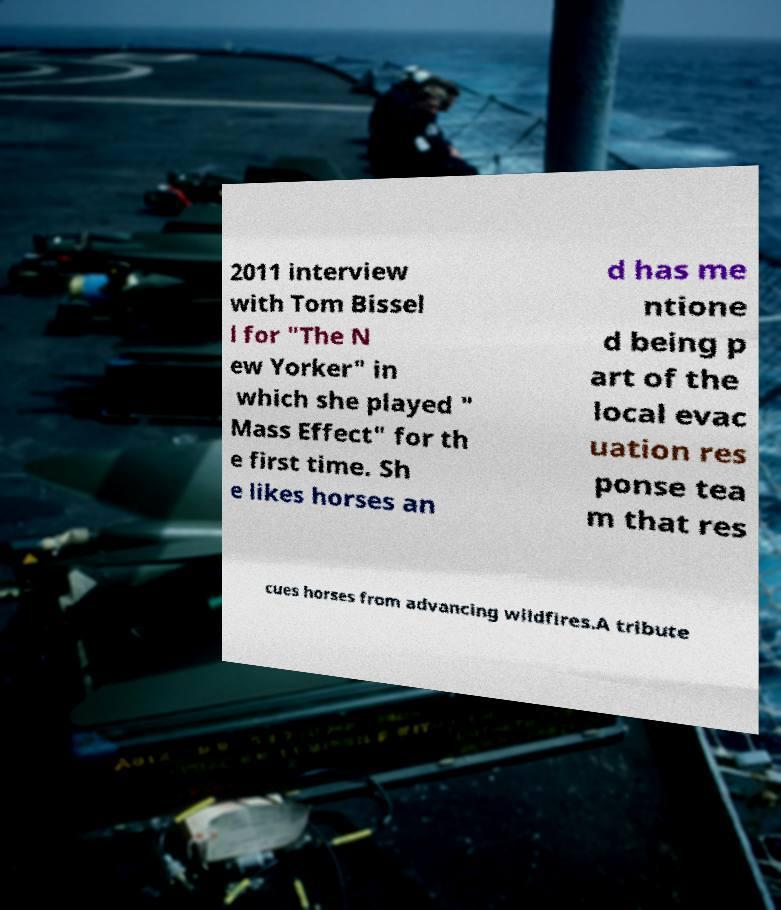Please read and relay the text visible in this image. What does it say? 2011 interview with Tom Bissel l for "The N ew Yorker" in which she played " Mass Effect" for th e first time. Sh e likes horses an d has me ntione d being p art of the local evac uation res ponse tea m that res cues horses from advancing wildfires.A tribute 